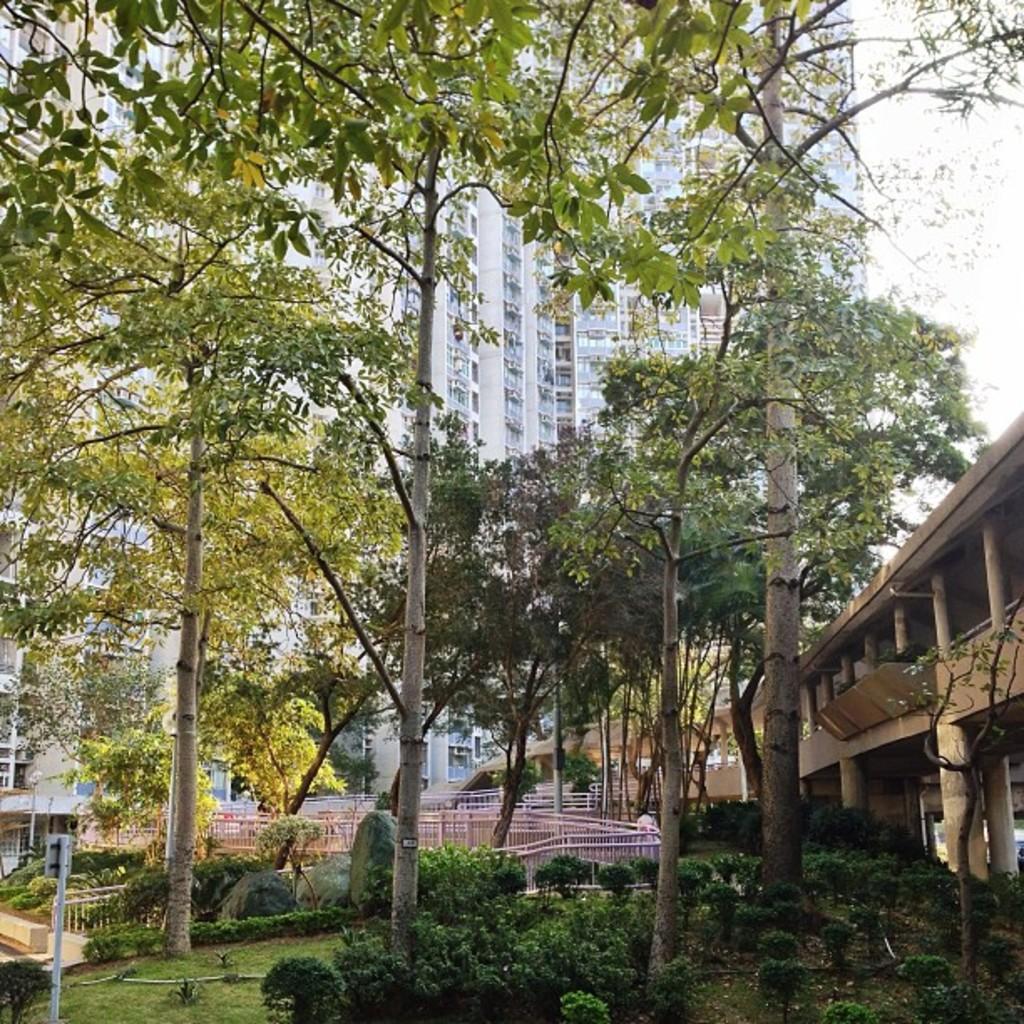In one or two sentences, can you explain what this image depicts? It is a garden with some tall trees and plants and behind the garden there is a huge building. 